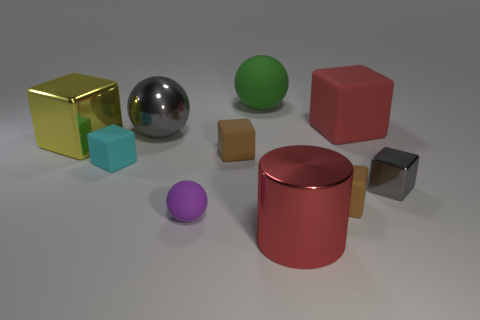There is a small purple thing that is made of the same material as the cyan cube; what is its shape?
Make the answer very short. Sphere. Are there any large cylinders that have the same color as the large matte cube?
Provide a succinct answer. Yes. What is the material of the cyan thing?
Offer a very short reply. Rubber. What number of objects are tiny matte cubes or small yellow matte cubes?
Offer a terse response. 3. What size is the gray shiny thing in front of the large yellow cube?
Your response must be concise. Small. How many other objects are there of the same material as the purple ball?
Offer a very short reply. 5. Are there any small purple rubber balls left of the rubber ball that is in front of the red cube?
Your response must be concise. No. Are there any other things that are the same shape as the red shiny thing?
Your answer should be very brief. No. There is another big shiny object that is the same shape as the cyan thing; what color is it?
Make the answer very short. Yellow. What is the size of the red matte cube?
Provide a short and direct response. Large. 